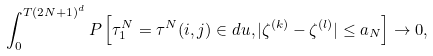<formula> <loc_0><loc_0><loc_500><loc_500>\int _ { 0 } ^ { T ( 2 N + 1 ) ^ { d } } P \left [ \tau _ { 1 } ^ { N } = \tau ^ { N } ( i , j ) \in d u , | \zeta ^ { ( k ) } - \zeta ^ { ( l ) } | \leq a _ { N } \right ] \to 0 ,</formula> 